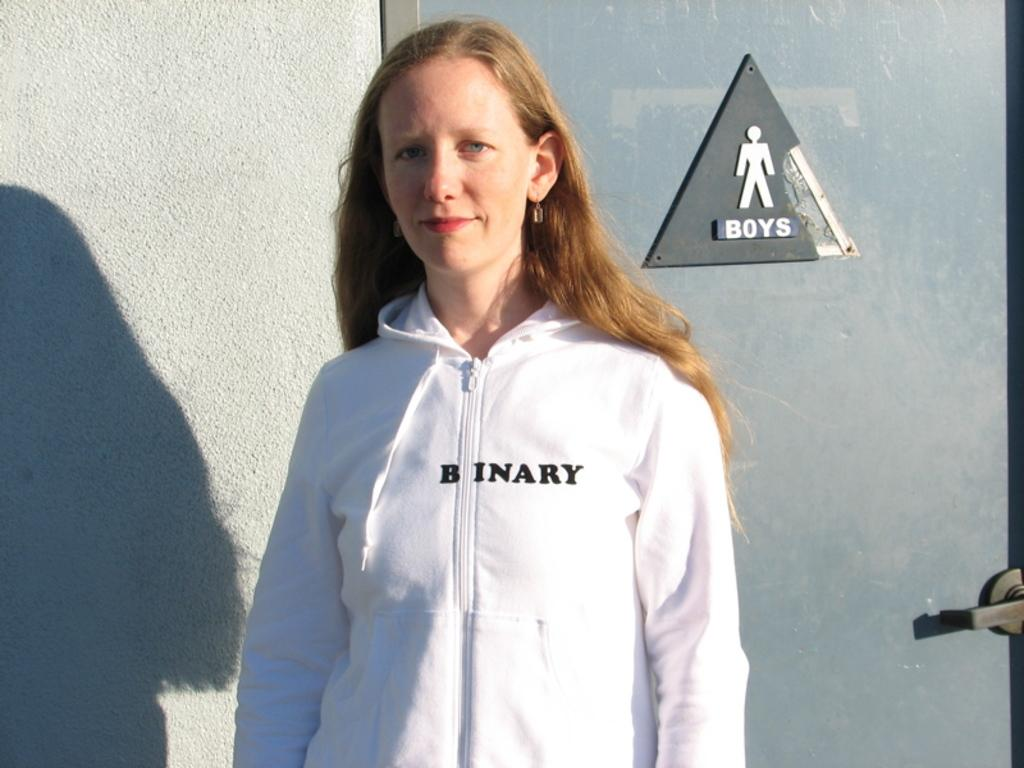<image>
Offer a succinct explanation of the picture presented. A woman in a white jacket that says Binary on it. 